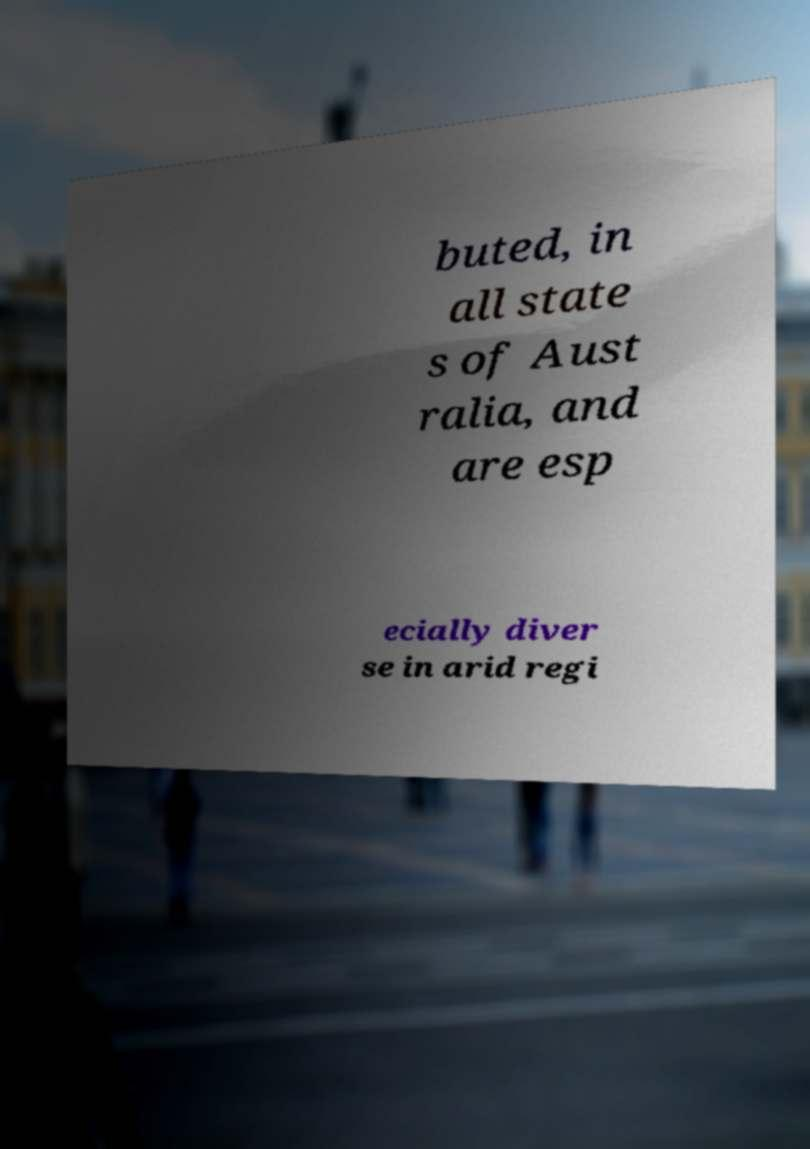Can you read and provide the text displayed in the image?This photo seems to have some interesting text. Can you extract and type it out for me? buted, in all state s of Aust ralia, and are esp ecially diver se in arid regi 